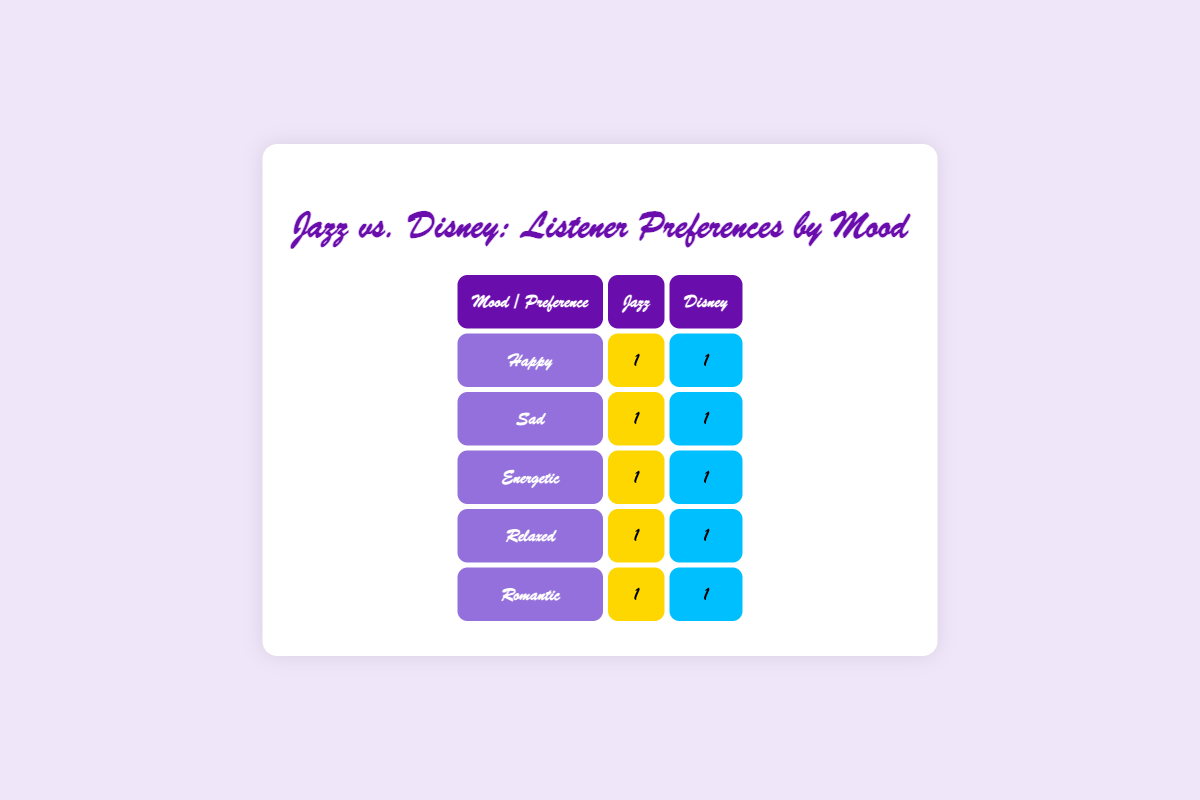What is the total number of listeners who prefer Jazz in a Happy mood? There is 1 listener in the Happy mood who prefers Jazz (Alice).
Answer: 1 How many listeners prefer Disney in a Sad mood? The table shows that there is 1 listener in the Sad mood who prefers Disney (Charlie).
Answer: 1 Is there a listener who prefers Jazz in an Energetic mood? Yes, there is 1 listener in the Energetic mood who prefers Jazz (Ethan).
Answer: Yes How many total listeners chose Jazz across all moods? By counting the Jazz preferences in the table: Happy (1), Sad (1), Energetic (1), Relaxed (1), and Romantic (1), we have a total of 5 listeners who prefer Jazz.
Answer: 5 What mood has the highest preference for Disney music? All moods have equal representation for Disney preferences: each mood has 1 listener who prefers Disney. Thus, there is no specific mood with the highest preference; they are all equal.
Answer: None Are there more listeners who prefer Jazz or Disney overall? Both Jazz and Disney have 5 total listeners each (Jazz: 5, Disney: 5); thus, the totals are equal.
Answer: Equal Which mood has the same number of listeners preferring Jazz and Disney? All moods—Happy, Sad, Energetic, Relaxed, and Romantic—have the same number of listeners preferring Jazz and Disney (1 for each).
Answer: All moods How many listeners prefer Disney in a Romantic mood? The table shows there is 1 listener in the Romantic mood who prefers Disney (Jessica).
Answer: 1 What is the total number of listeners who participated in the survey? There are a total of 10 listeners listed: Alice, Bob, Charlie, Dana, Ethan, Fiona, George, Hannah, Ian, and Jessica.
Answer: 10 